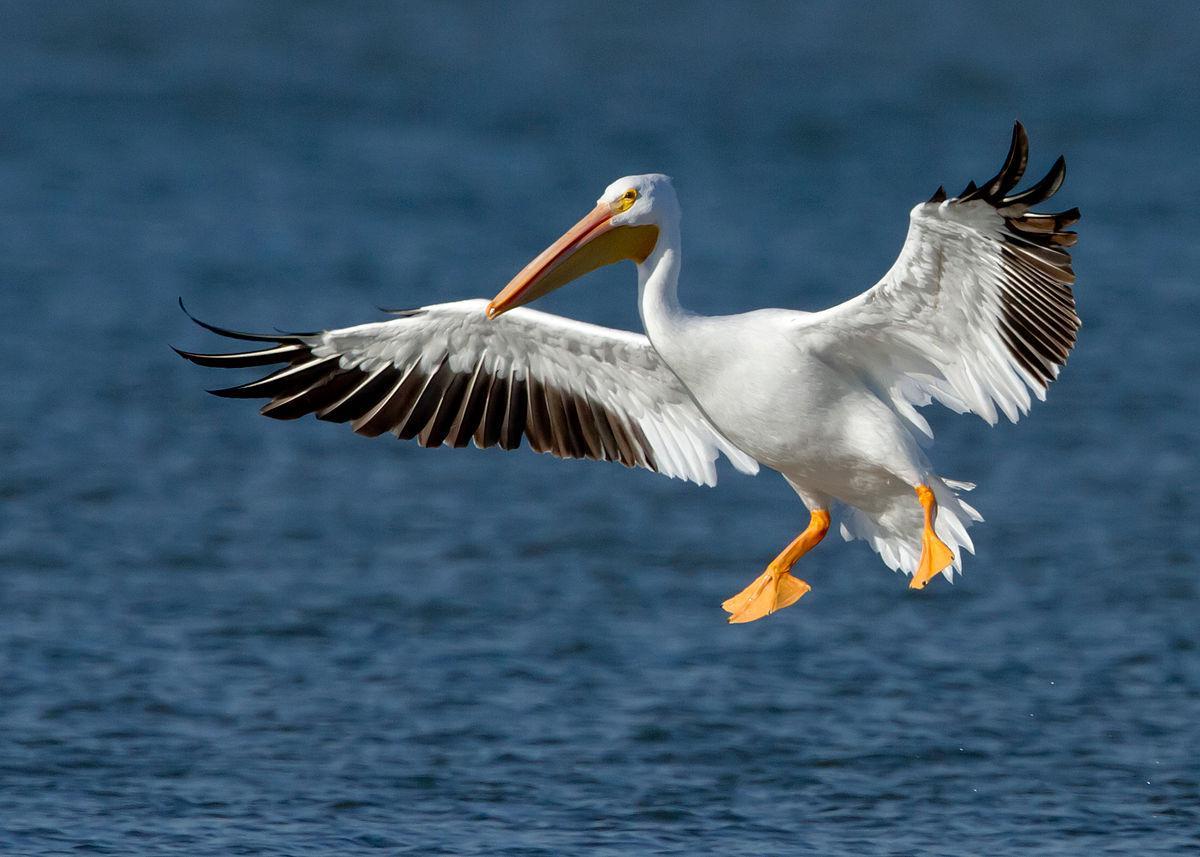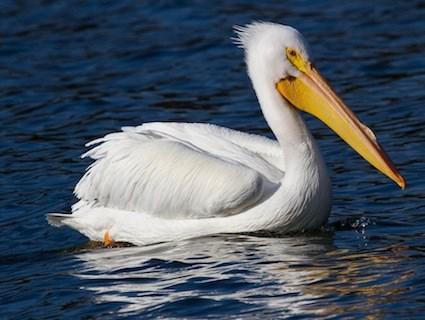The first image is the image on the left, the second image is the image on the right. Considering the images on both sides, is "One of the birds has its wings spread." valid? Answer yes or no. Yes. 